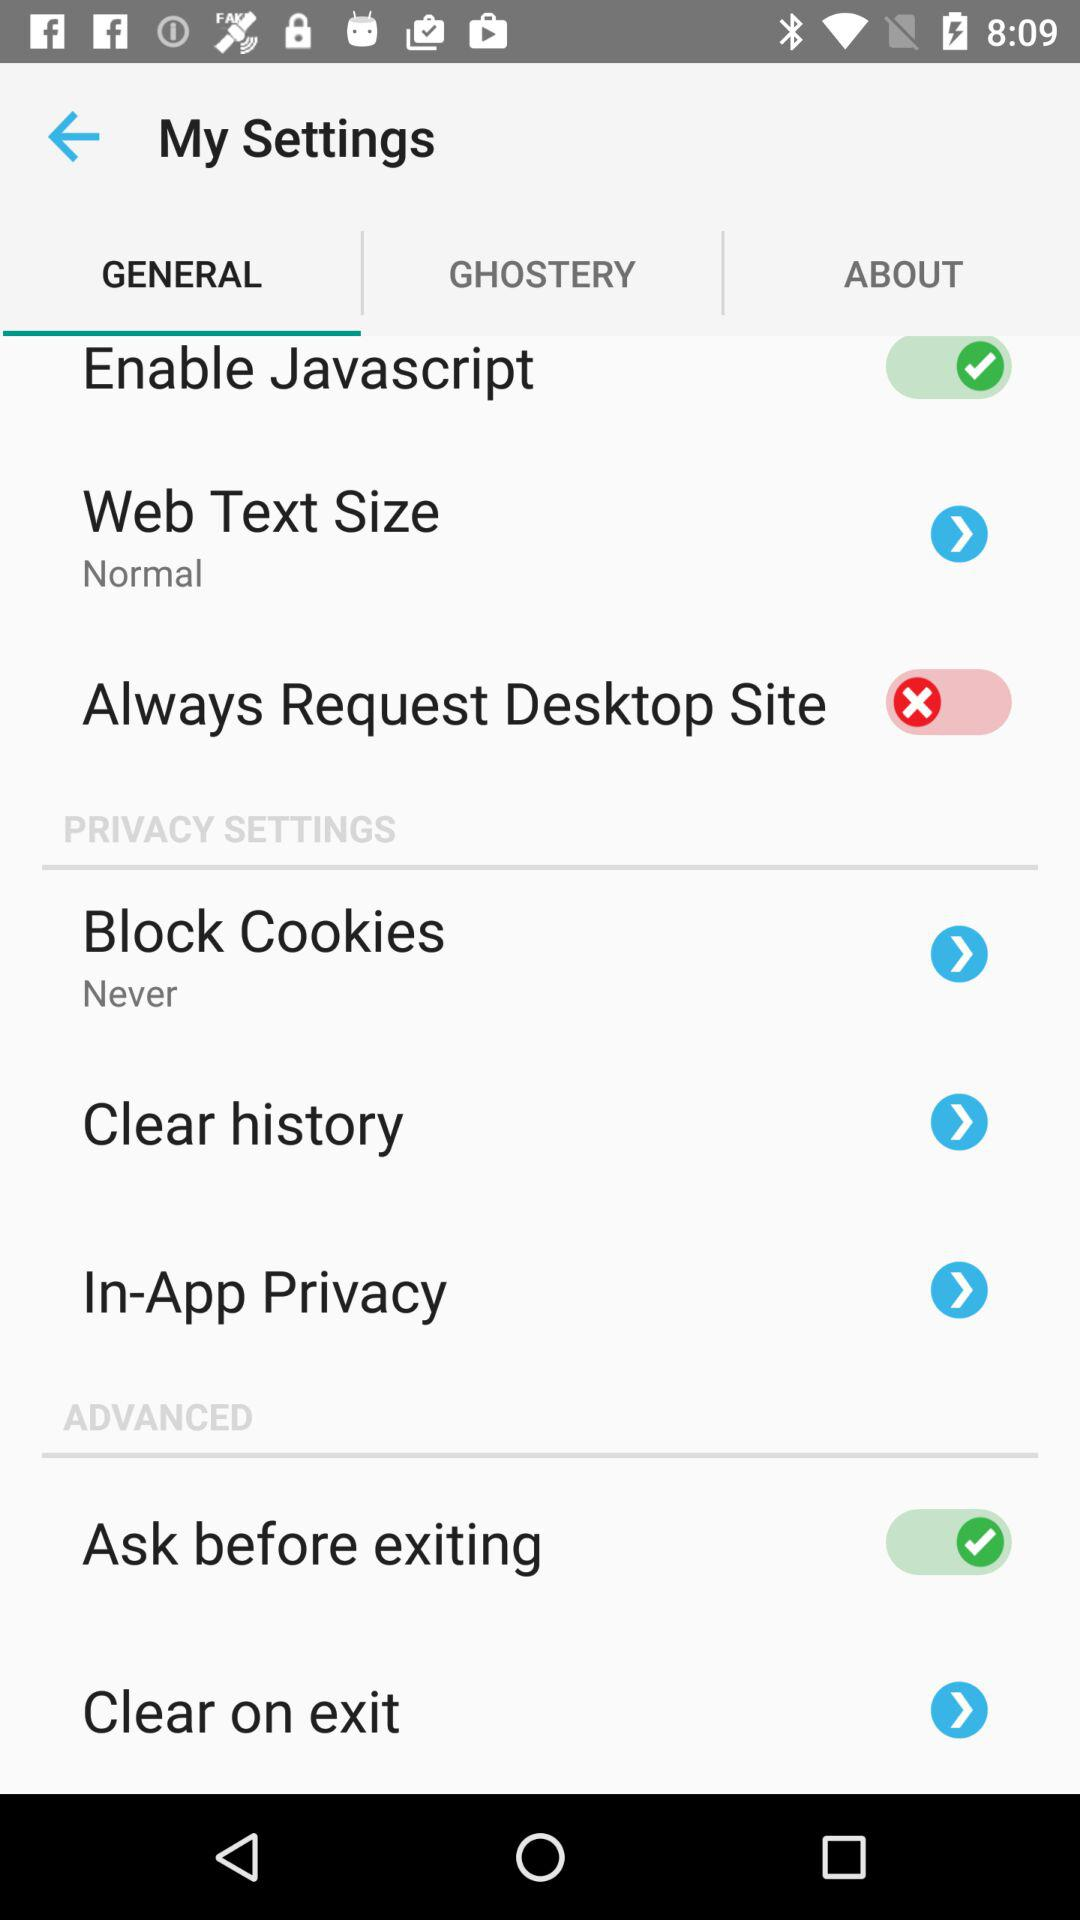What is the web text size? The web text size is normal. 